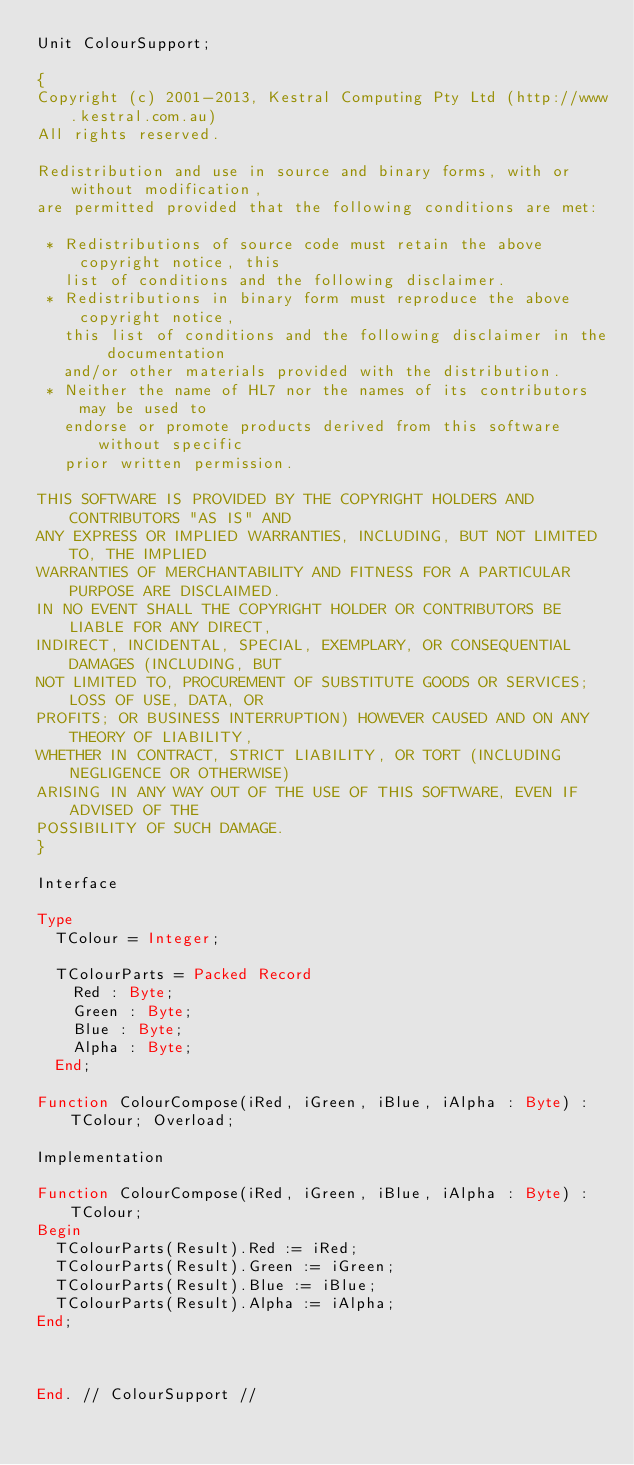Convert code to text. <code><loc_0><loc_0><loc_500><loc_500><_Pascal_>Unit ColourSupport;

{
Copyright (c) 2001-2013, Kestral Computing Pty Ltd (http://www.kestral.com.au)
All rights reserved.

Redistribution and use in source and binary forms, with or without modification, 
are permitted provided that the following conditions are met:

 * Redistributions of source code must retain the above copyright notice, this 
   list of conditions and the following disclaimer.
 * Redistributions in binary form must reproduce the above copyright notice, 
   this list of conditions and the following disclaimer in the documentation 
   and/or other materials provided with the distribution.
 * Neither the name of HL7 nor the names of its contributors may be used to 
   endorse or promote products derived from this software without specific 
   prior written permission.

THIS SOFTWARE IS PROVIDED BY THE COPYRIGHT HOLDERS AND CONTRIBUTORS "AS IS" AND 
ANY EXPRESS OR IMPLIED WARRANTIES, INCLUDING, BUT NOT LIMITED TO, THE IMPLIED 
WARRANTIES OF MERCHANTABILITY AND FITNESS FOR A PARTICULAR PURPOSE ARE DISCLAIMED. 
IN NO EVENT SHALL THE COPYRIGHT HOLDER OR CONTRIBUTORS BE LIABLE FOR ANY DIRECT, 
INDIRECT, INCIDENTAL, SPECIAL, EXEMPLARY, OR CONSEQUENTIAL DAMAGES (INCLUDING, BUT 
NOT LIMITED TO, PROCUREMENT OF SUBSTITUTE GOODS OR SERVICES; LOSS OF USE, DATA, OR 
PROFITS; OR BUSINESS INTERRUPTION) HOWEVER CAUSED AND ON ANY THEORY OF LIABILITY, 
WHETHER IN CONTRACT, STRICT LIABILITY, OR TORT (INCLUDING NEGLIGENCE OR OTHERWISE) 
ARISING IN ANY WAY OUT OF THE USE OF THIS SOFTWARE, EVEN IF ADVISED OF THE 
POSSIBILITY OF SUCH DAMAGE.
}

Interface

Type
  TColour = Integer;

  TColourParts = Packed Record
    Red : Byte;
    Green : Byte;
    Blue : Byte;
    Alpha : Byte;
  End;

Function ColourCompose(iRed, iGreen, iBlue, iAlpha : Byte) : TColour; Overload;

Implementation

Function ColourCompose(iRed, iGreen, iBlue, iAlpha : Byte) : TColour;
Begin
  TColourParts(Result).Red := iRed;
  TColourParts(Result).Green := iGreen;
  TColourParts(Result).Blue := iBlue;
  TColourParts(Result).Alpha := iAlpha;
End;



End. // ColourSupport //

</code> 